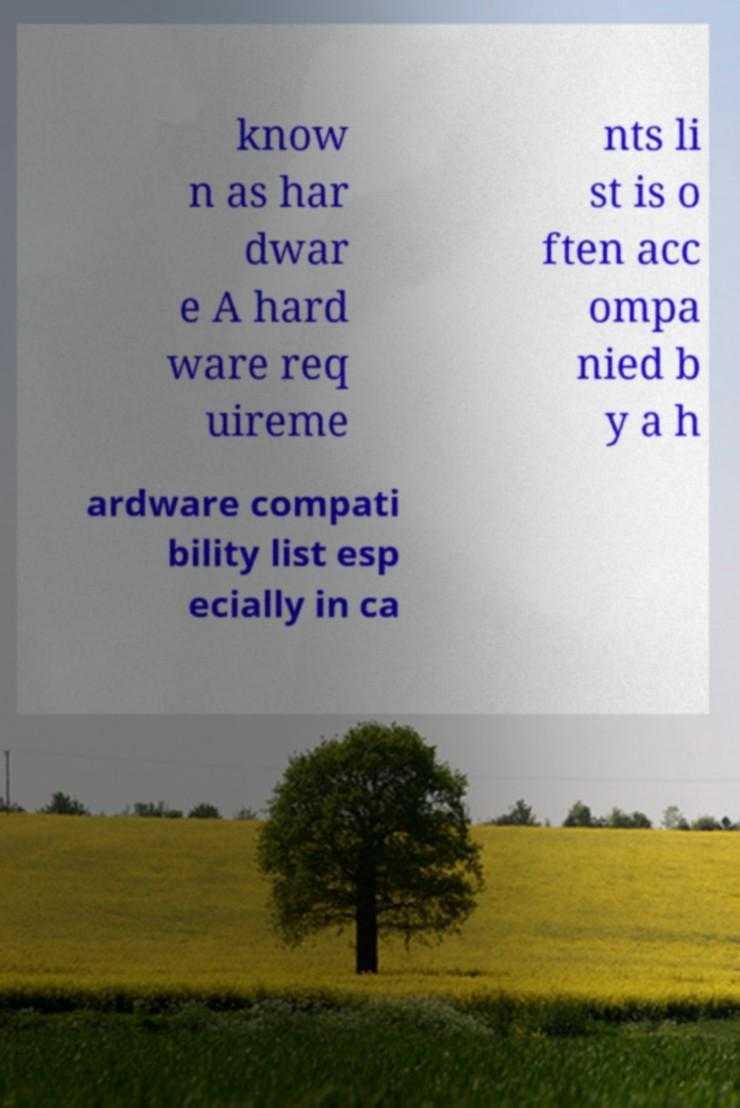Please read and relay the text visible in this image. What does it say? know n as har dwar e A hard ware req uireme nts li st is o ften acc ompa nied b y a h ardware compati bility list esp ecially in ca 